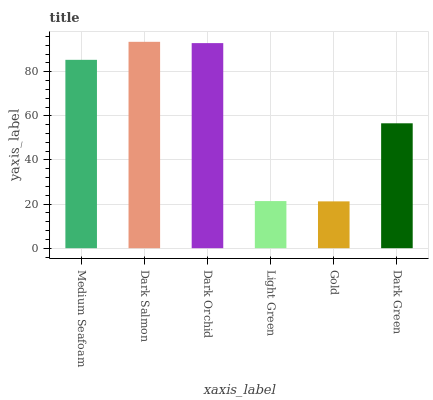Is Gold the minimum?
Answer yes or no. Yes. Is Dark Salmon the maximum?
Answer yes or no. Yes. Is Dark Orchid the minimum?
Answer yes or no. No. Is Dark Orchid the maximum?
Answer yes or no. No. Is Dark Salmon greater than Dark Orchid?
Answer yes or no. Yes. Is Dark Orchid less than Dark Salmon?
Answer yes or no. Yes. Is Dark Orchid greater than Dark Salmon?
Answer yes or no. No. Is Dark Salmon less than Dark Orchid?
Answer yes or no. No. Is Medium Seafoam the high median?
Answer yes or no. Yes. Is Dark Green the low median?
Answer yes or no. Yes. Is Dark Orchid the high median?
Answer yes or no. No. Is Light Green the low median?
Answer yes or no. No. 